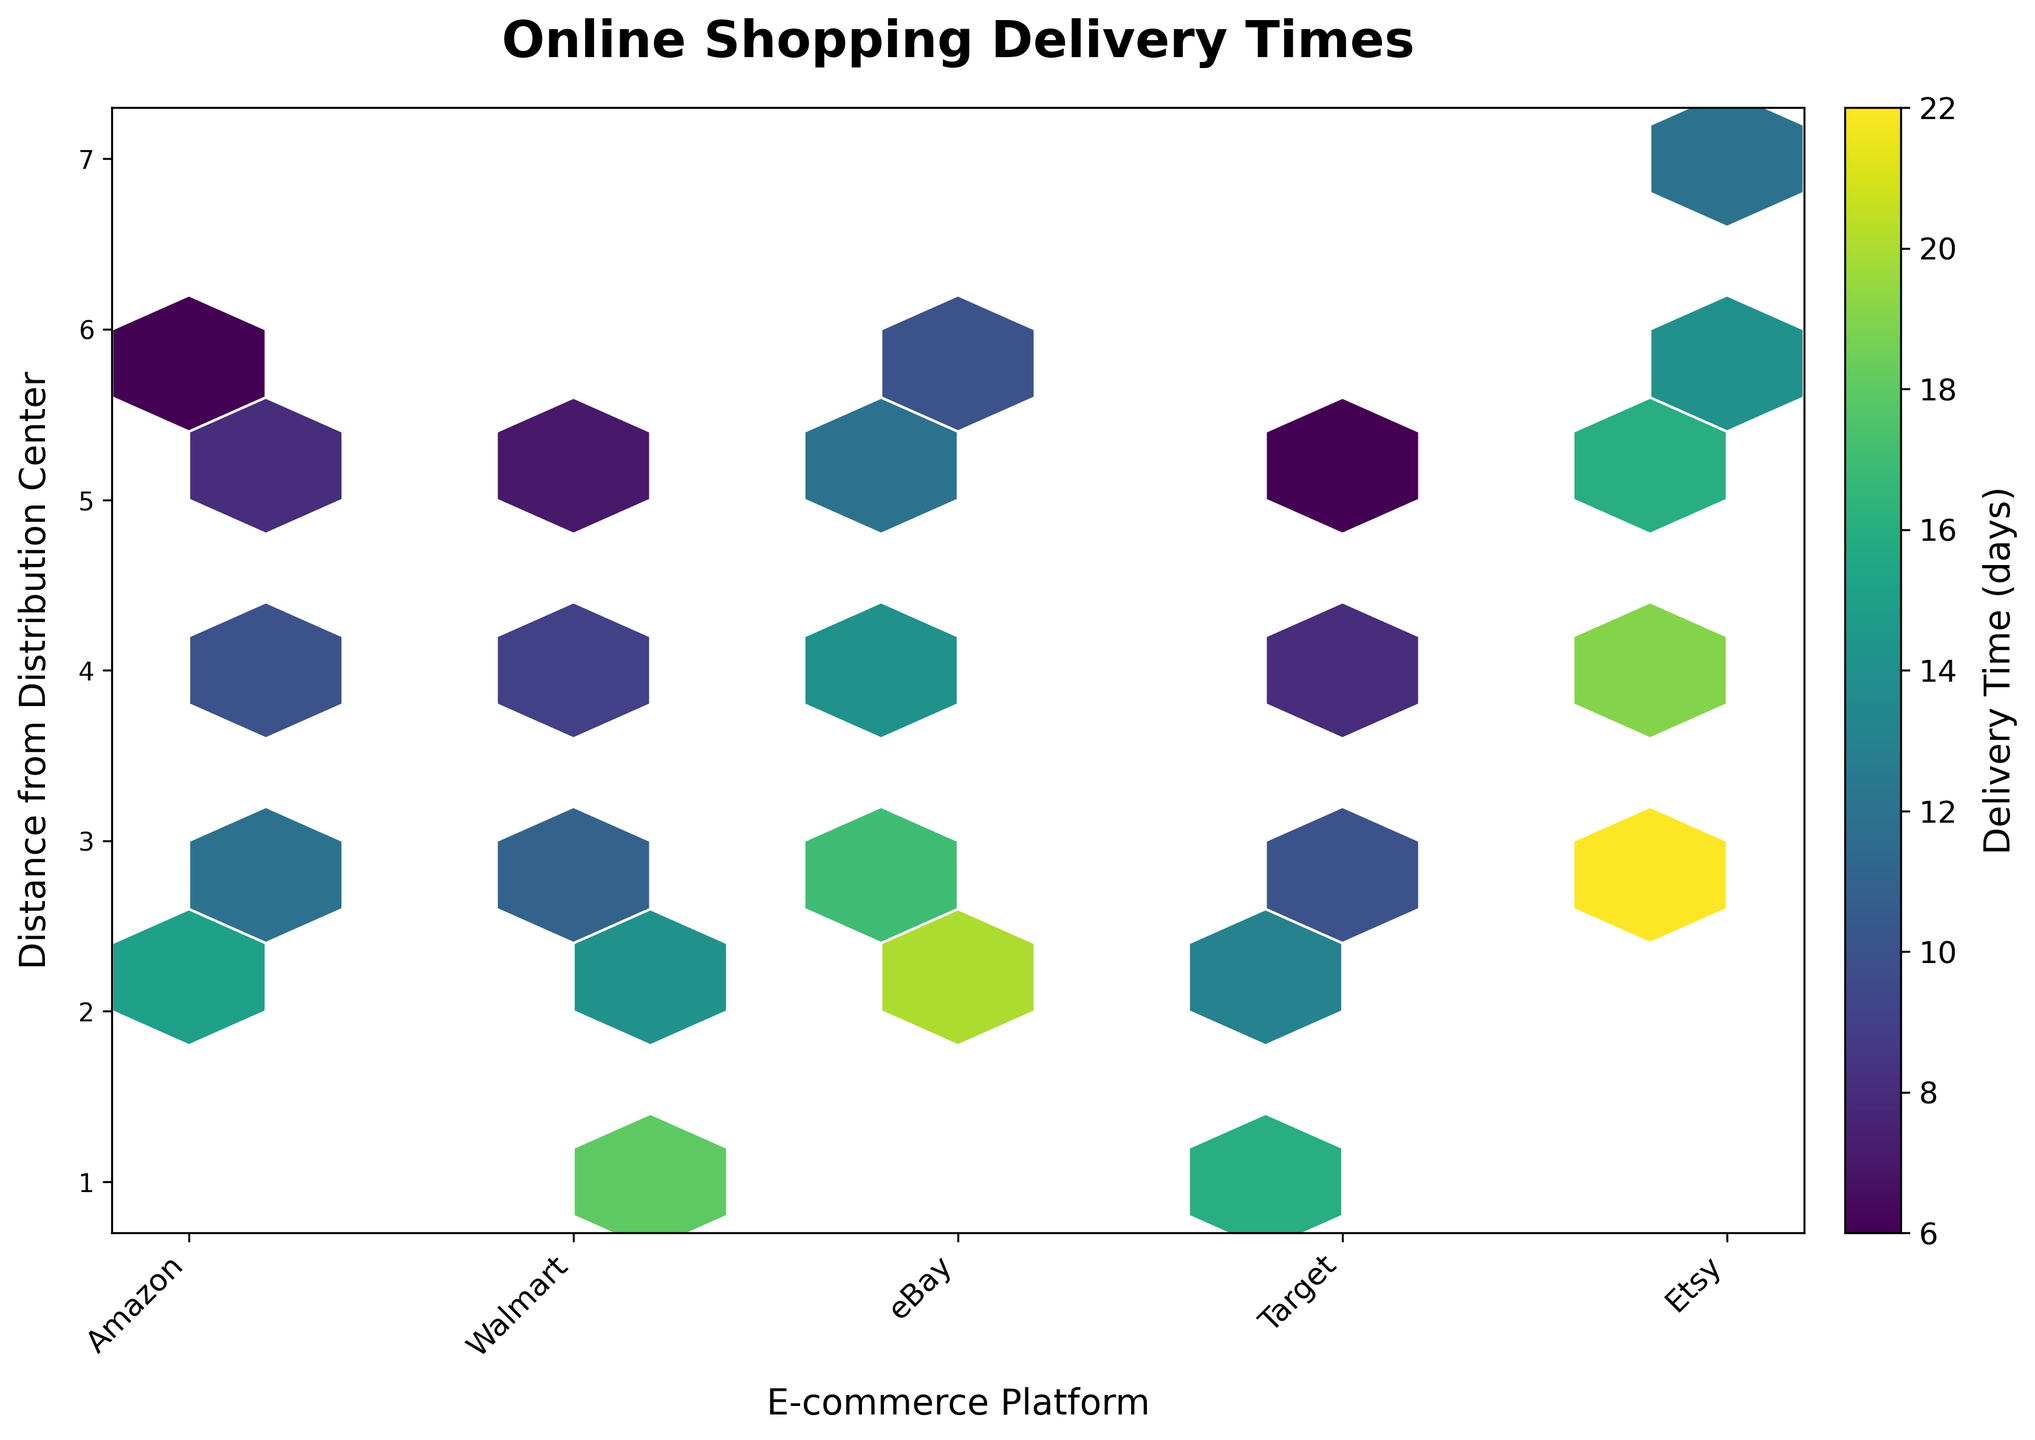What is the title of the plot? The title is displayed at the top center of the plot.
Answer: Online Shopping Delivery Times What does the colorbar represent? The colorbar on the right side of the plot shows the mapping between colors and numerical values representing delivery time in days.
Answer: Delivery Time (days) Which e-commerce platform seems to have the shortest overall delivery times? By observing the color intensity in the hexagons, Amazon has the darkest colors overall, indicating shorter delivery times.
Answer: Amazon For eBay, what is the general trend of delivery time as the distance increases from the distribution center? For eBay, as the distance increases on the y-axis, the delivery time also increases, which is evident from the changing color intensity from light to dark.
Answer: Increases How does the delivery time for Etsy at a distance of 6 compare to Amazon at the same distance? By comparing the color intensity of the corresponding hexagons for a distance of 6, Etsy has a darker hexagon than Amazon, indicating a longer delivery time.
Answer: Etsy is longer What is the general trend in delivery time for Walmart as the distance increases? For Walmart, the delivery time decreases as the distance increases, shown by the decreasing color intensity from darker to lighter.
Answer: Decreases Which e-commerce platform appears to have the most variation in delivery times across different distances? By analyzing the color variations within each platform's row, Etsy shows significant variation, evidenced by a wider range of color intensities.
Answer: Etsy Which platform has the darkest hexagon representing the shortest delivery time at the shortest distance? The darkest hexagon at the shortest distance (y=1) is observed under Walmart.
Answer: Walmart If you only look at distances between 4 and 5 from the distribution center, which platform has the lowest delivery time? Observing hexagons at distances of 4 and 5, Amazon has lighter colors compared to other platforms, indicating lower delivery times.
Answer: Amazon Does Target have a consistent delivery time across different distances? The hexagons in the row for Target follow a trend of decreasing color intensity, suggesting consistent delivery time reduction as the distance from the distribution center increases.
Answer: No, it decreases 